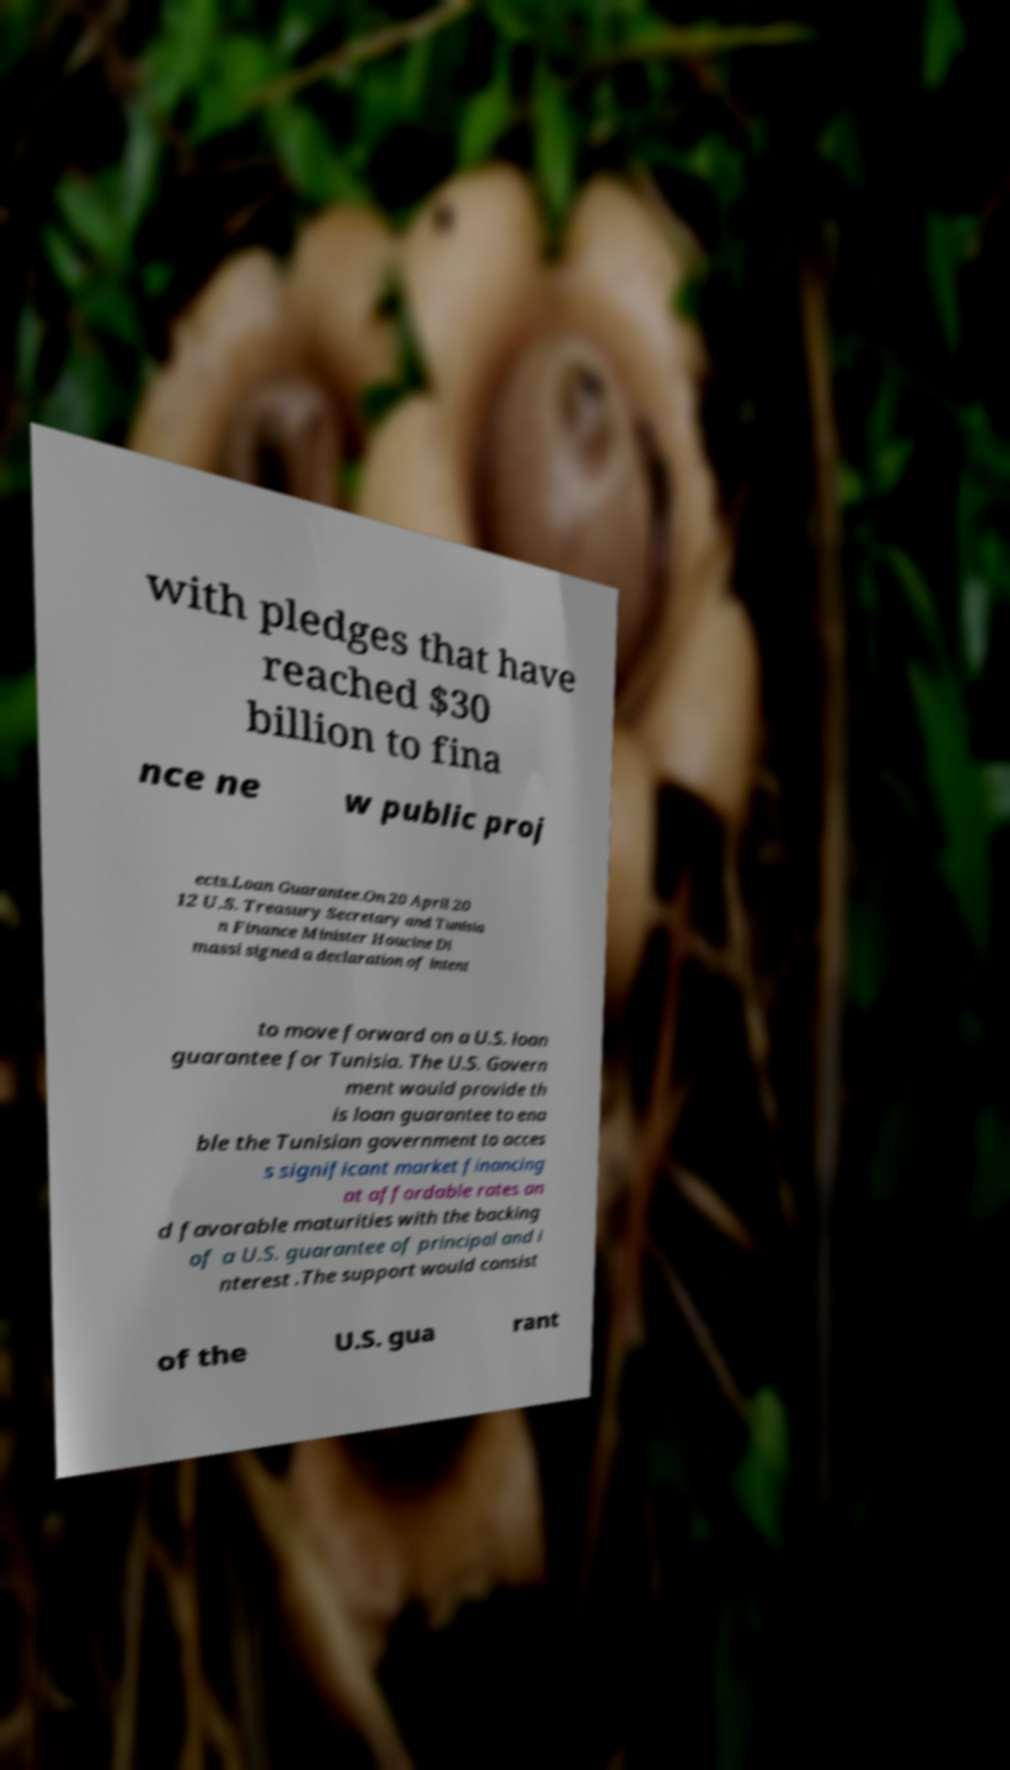Could you assist in decoding the text presented in this image and type it out clearly? with pledges that have reached $30 billion to fina nce ne w public proj ects.Loan Guarantee.On 20 April 20 12 U.S. Treasury Secretary and Tunisia n Finance Minister Houcine Di massi signed a declaration of intent to move forward on a U.S. loan guarantee for Tunisia. The U.S. Govern ment would provide th is loan guarantee to ena ble the Tunisian government to acces s significant market financing at affordable rates an d favorable maturities with the backing of a U.S. guarantee of principal and i nterest .The support would consist of the U.S. gua rant 